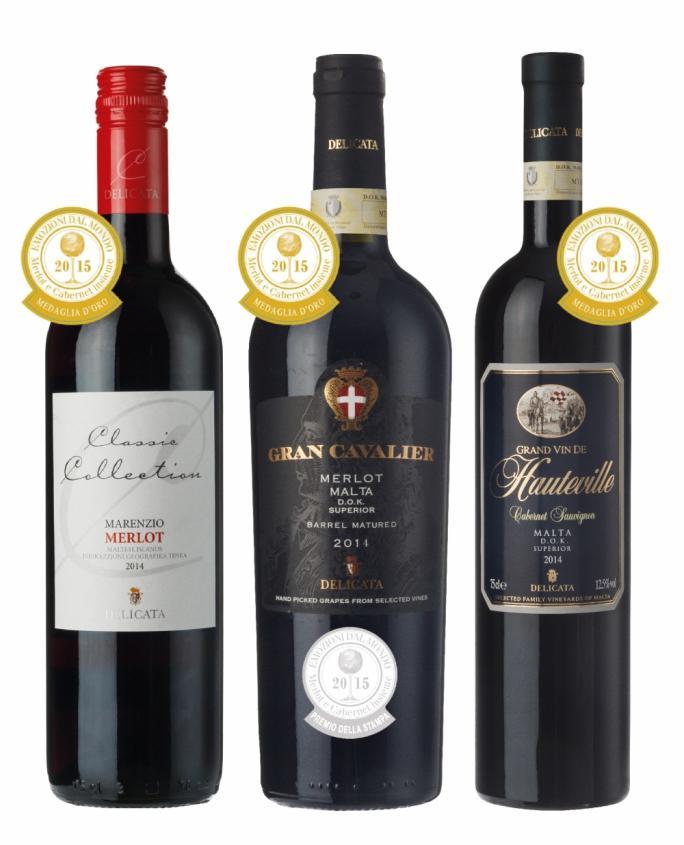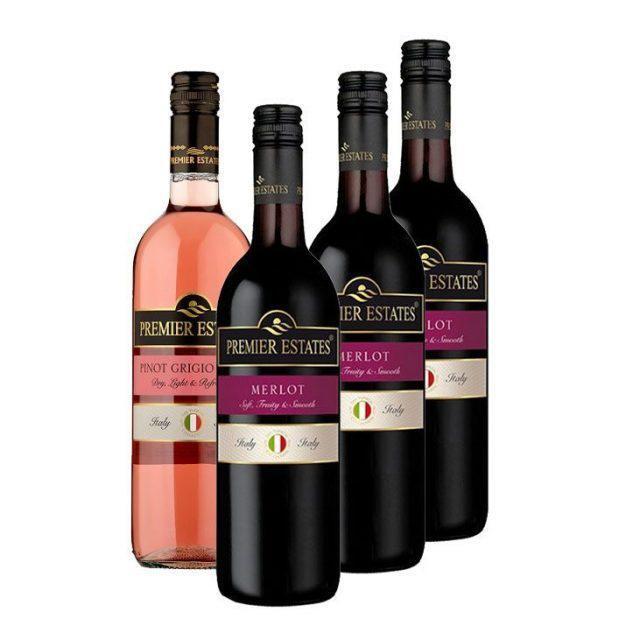The first image is the image on the left, the second image is the image on the right. Considering the images on both sides, is "There are fewer than 4 bottles across both images." valid? Answer yes or no. No. The first image is the image on the left, the second image is the image on the right. Assess this claim about the two images: "One image contains a horizontal row of three wine bottles.". Correct or not? Answer yes or no. Yes. 